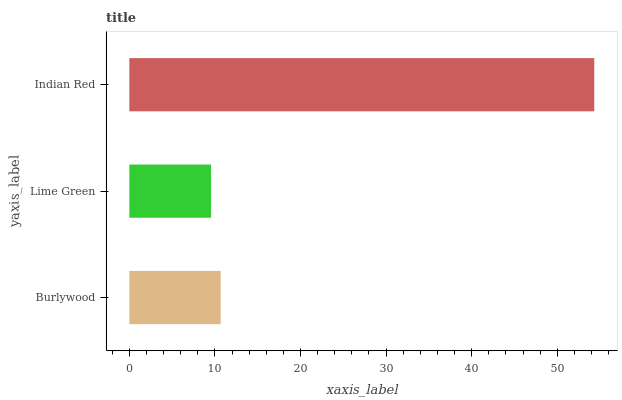Is Lime Green the minimum?
Answer yes or no. Yes. Is Indian Red the maximum?
Answer yes or no. Yes. Is Indian Red the minimum?
Answer yes or no. No. Is Lime Green the maximum?
Answer yes or no. No. Is Indian Red greater than Lime Green?
Answer yes or no. Yes. Is Lime Green less than Indian Red?
Answer yes or no. Yes. Is Lime Green greater than Indian Red?
Answer yes or no. No. Is Indian Red less than Lime Green?
Answer yes or no. No. Is Burlywood the high median?
Answer yes or no. Yes. Is Burlywood the low median?
Answer yes or no. Yes. Is Lime Green the high median?
Answer yes or no. No. Is Lime Green the low median?
Answer yes or no. No. 